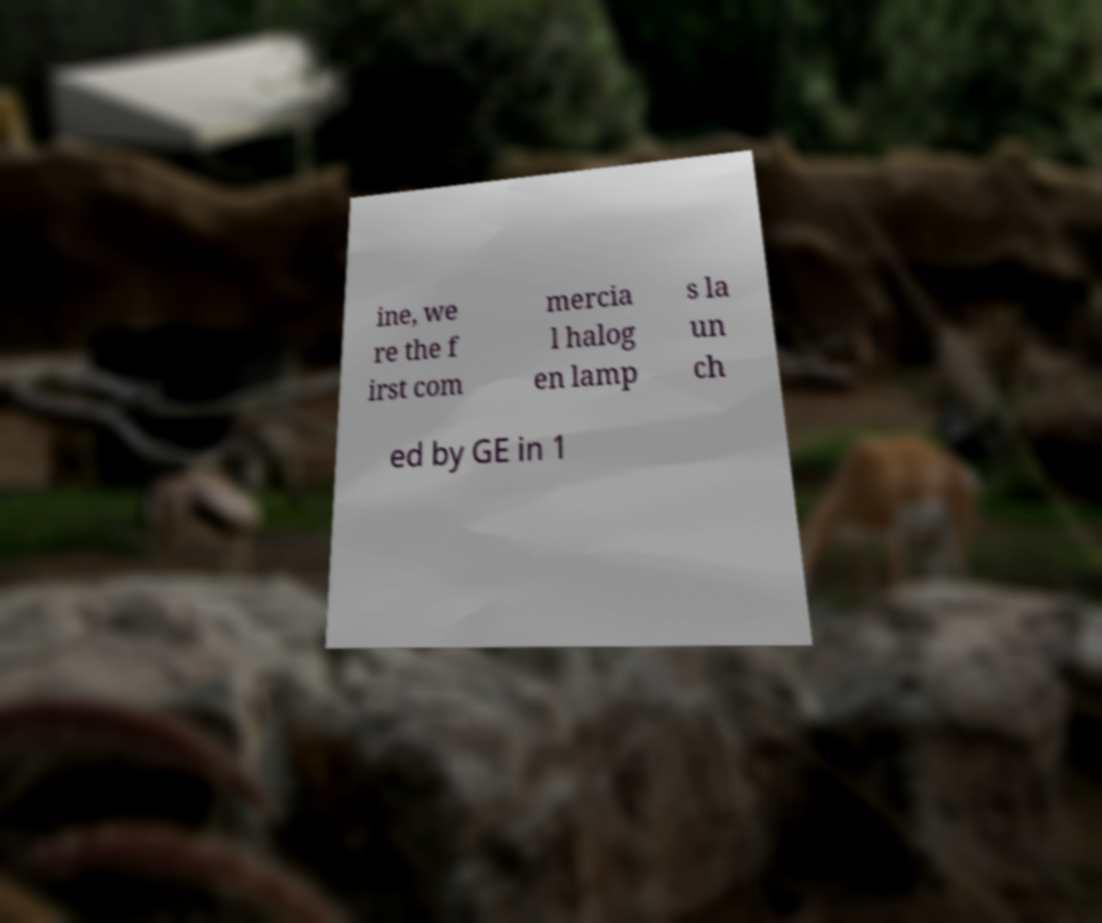Please read and relay the text visible in this image. What does it say? ine, we re the f irst com mercia l halog en lamp s la un ch ed by GE in 1 